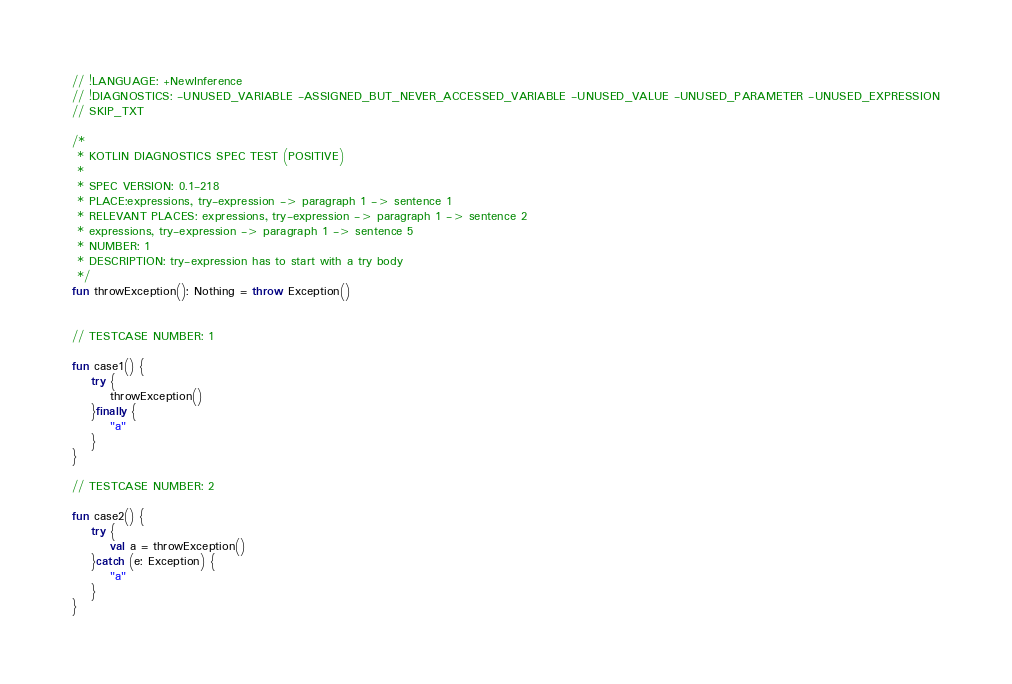Convert code to text. <code><loc_0><loc_0><loc_500><loc_500><_Kotlin_>// !LANGUAGE: +NewInference
// !DIAGNOSTICS: -UNUSED_VARIABLE -ASSIGNED_BUT_NEVER_ACCESSED_VARIABLE -UNUSED_VALUE -UNUSED_PARAMETER -UNUSED_EXPRESSION
// SKIP_TXT

/*
 * KOTLIN DIAGNOSTICS SPEC TEST (POSITIVE)
 *
 * SPEC VERSION: 0.1-218
 * PLACE:expressions, try-expression -> paragraph 1 -> sentence 1
 * RELEVANT PLACES: expressions, try-expression -> paragraph 1 -> sentence 2
 * expressions, try-expression -> paragraph 1 -> sentence 5
 * NUMBER: 1
 * DESCRIPTION: try-expression has to start with a try body
 */
fun throwException(): Nothing = throw Exception()


// TESTCASE NUMBER: 1

fun case1() {
    try {
        throwException()
    }finally {
        "a"
    }
}

// TESTCASE NUMBER: 2

fun case2() {
    try {
        val a = throwException()
    }catch (e: Exception) {
        "a"
    }
}
</code> 